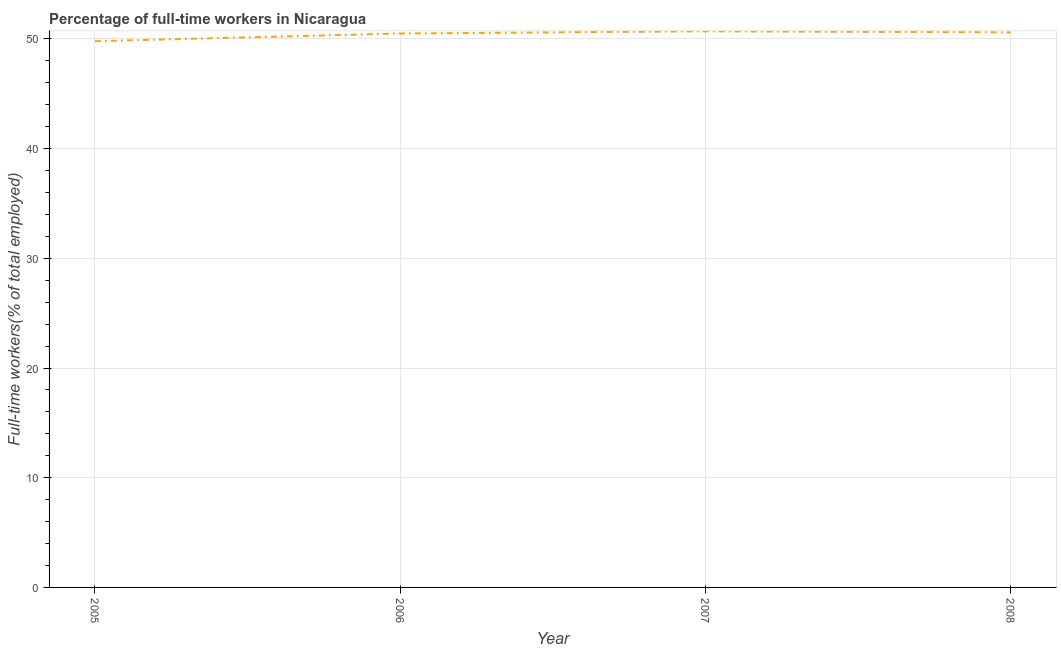What is the percentage of full-time workers in 2006?
Your answer should be very brief. 50.5. Across all years, what is the maximum percentage of full-time workers?
Offer a very short reply. 50.7. Across all years, what is the minimum percentage of full-time workers?
Ensure brevity in your answer.  49.8. In which year was the percentage of full-time workers maximum?
Offer a terse response. 2007. What is the sum of the percentage of full-time workers?
Make the answer very short. 201.6. What is the difference between the percentage of full-time workers in 2006 and 2008?
Your response must be concise. -0.1. What is the average percentage of full-time workers per year?
Keep it short and to the point. 50.4. What is the median percentage of full-time workers?
Give a very brief answer. 50.55. In how many years, is the percentage of full-time workers greater than 18 %?
Keep it short and to the point. 4. Do a majority of the years between 2005 and 2007 (inclusive) have percentage of full-time workers greater than 36 %?
Your answer should be compact. Yes. What is the ratio of the percentage of full-time workers in 2006 to that in 2008?
Ensure brevity in your answer.  1. Is the difference between the percentage of full-time workers in 2005 and 2008 greater than the difference between any two years?
Your answer should be very brief. No. What is the difference between the highest and the second highest percentage of full-time workers?
Provide a succinct answer. 0.1. What is the difference between the highest and the lowest percentage of full-time workers?
Your answer should be very brief. 0.9. In how many years, is the percentage of full-time workers greater than the average percentage of full-time workers taken over all years?
Your answer should be compact. 3. How many lines are there?
Your answer should be compact. 1. What is the difference between two consecutive major ticks on the Y-axis?
Offer a terse response. 10. Does the graph contain any zero values?
Your response must be concise. No. Does the graph contain grids?
Provide a succinct answer. Yes. What is the title of the graph?
Ensure brevity in your answer.  Percentage of full-time workers in Nicaragua. What is the label or title of the X-axis?
Provide a succinct answer. Year. What is the label or title of the Y-axis?
Provide a short and direct response. Full-time workers(% of total employed). What is the Full-time workers(% of total employed) of 2005?
Ensure brevity in your answer.  49.8. What is the Full-time workers(% of total employed) in 2006?
Provide a succinct answer. 50.5. What is the Full-time workers(% of total employed) in 2007?
Your answer should be compact. 50.7. What is the Full-time workers(% of total employed) of 2008?
Ensure brevity in your answer.  50.6. What is the difference between the Full-time workers(% of total employed) in 2005 and 2006?
Offer a terse response. -0.7. What is the difference between the Full-time workers(% of total employed) in 2005 and 2007?
Ensure brevity in your answer.  -0.9. What is the difference between the Full-time workers(% of total employed) in 2006 and 2007?
Your answer should be very brief. -0.2. What is the difference between the Full-time workers(% of total employed) in 2006 and 2008?
Your response must be concise. -0.1. What is the difference between the Full-time workers(% of total employed) in 2007 and 2008?
Your response must be concise. 0.1. What is the ratio of the Full-time workers(% of total employed) in 2005 to that in 2007?
Offer a very short reply. 0.98. What is the ratio of the Full-time workers(% of total employed) in 2005 to that in 2008?
Keep it short and to the point. 0.98. 